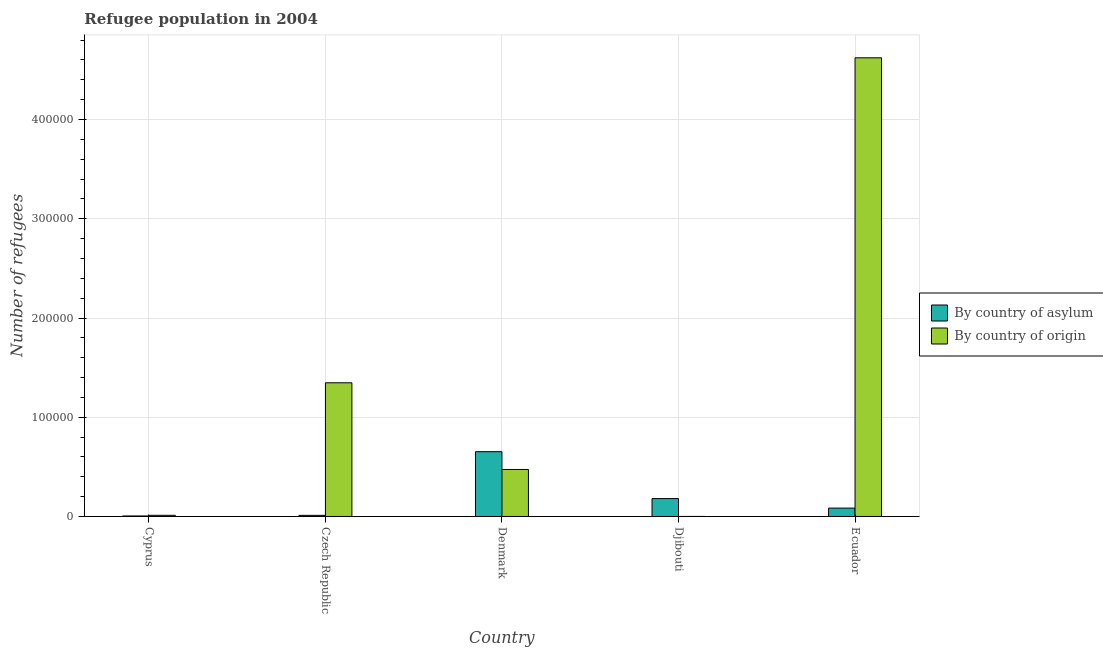Are the number of bars per tick equal to the number of legend labels?
Keep it short and to the point. Yes. How many bars are there on the 1st tick from the left?
Your answer should be compact. 2. What is the label of the 4th group of bars from the left?
Provide a succinct answer. Djibouti. In how many cases, is the number of bars for a given country not equal to the number of legend labels?
Your answer should be compact. 0. What is the number of refugees by country of origin in Czech Republic?
Your answer should be compact. 1.35e+05. Across all countries, what is the maximum number of refugees by country of asylum?
Your answer should be very brief. 6.53e+04. Across all countries, what is the minimum number of refugees by country of asylum?
Offer a terse response. 531. In which country was the number of refugees by country of origin minimum?
Ensure brevity in your answer.  Djibouti. What is the total number of refugees by country of origin in the graph?
Offer a very short reply. 6.46e+05. What is the difference between the number of refugees by country of asylum in Djibouti and that in Ecuador?
Provide a short and direct response. 9585. What is the difference between the number of refugees by country of asylum in Djibouti and the number of refugees by country of origin in Cyprus?
Provide a succinct answer. 1.68e+04. What is the average number of refugees by country of asylum per country?
Ensure brevity in your answer.  1.87e+04. What is the difference between the number of refugees by country of asylum and number of refugees by country of origin in Djibouti?
Provide a succinct answer. 1.80e+04. In how many countries, is the number of refugees by country of origin greater than 20000 ?
Give a very brief answer. 3. What is the ratio of the number of refugees by country of asylum in Cyprus to that in Czech Republic?
Your answer should be very brief. 0.46. Is the number of refugees by country of origin in Czech Republic less than that in Djibouti?
Provide a short and direct response. No. What is the difference between the highest and the second highest number of refugees by country of asylum?
Your answer should be very brief. 4.73e+04. What is the difference between the highest and the lowest number of refugees by country of asylum?
Provide a succinct answer. 6.48e+04. In how many countries, is the number of refugees by country of asylum greater than the average number of refugees by country of asylum taken over all countries?
Your answer should be very brief. 1. Is the sum of the number of refugees by country of asylum in Djibouti and Ecuador greater than the maximum number of refugees by country of origin across all countries?
Keep it short and to the point. No. What does the 2nd bar from the left in Ecuador represents?
Offer a very short reply. By country of origin. What does the 1st bar from the right in Djibouti represents?
Keep it short and to the point. By country of origin. How many bars are there?
Your response must be concise. 10. Are all the bars in the graph horizontal?
Offer a very short reply. No. What is the difference between two consecutive major ticks on the Y-axis?
Make the answer very short. 1.00e+05. How many legend labels are there?
Your answer should be very brief. 2. How are the legend labels stacked?
Make the answer very short. Vertical. What is the title of the graph?
Ensure brevity in your answer.  Refugee population in 2004. Does "Net National savings" appear as one of the legend labels in the graph?
Offer a very short reply. No. What is the label or title of the X-axis?
Give a very brief answer. Country. What is the label or title of the Y-axis?
Offer a very short reply. Number of refugees. What is the Number of refugees in By country of asylum in Cyprus?
Offer a terse response. 531. What is the Number of refugees of By country of origin in Cyprus?
Make the answer very short. 1194. What is the Number of refugees in By country of asylum in Czech Republic?
Your answer should be very brief. 1144. What is the Number of refugees of By country of origin in Czech Republic?
Provide a short and direct response. 1.35e+05. What is the Number of refugees of By country of asylum in Denmark?
Give a very brief answer. 6.53e+04. What is the Number of refugees in By country of origin in Denmark?
Your answer should be compact. 4.74e+04. What is the Number of refugees in By country of asylum in Djibouti?
Ensure brevity in your answer.  1.80e+04. What is the Number of refugees in By country of origin in Djibouti?
Your answer should be very brief. 50. What is the Number of refugees of By country of asylum in Ecuador?
Your response must be concise. 8450. What is the Number of refugees of By country of origin in Ecuador?
Ensure brevity in your answer.  4.62e+05. Across all countries, what is the maximum Number of refugees in By country of asylum?
Make the answer very short. 6.53e+04. Across all countries, what is the maximum Number of refugees in By country of origin?
Your answer should be very brief. 4.62e+05. Across all countries, what is the minimum Number of refugees of By country of asylum?
Give a very brief answer. 531. What is the total Number of refugees of By country of asylum in the graph?
Your answer should be compact. 9.35e+04. What is the total Number of refugees of By country of origin in the graph?
Keep it short and to the point. 6.46e+05. What is the difference between the Number of refugees of By country of asylum in Cyprus and that in Czech Republic?
Offer a very short reply. -613. What is the difference between the Number of refugees in By country of origin in Cyprus and that in Czech Republic?
Provide a succinct answer. -1.34e+05. What is the difference between the Number of refugees in By country of asylum in Cyprus and that in Denmark?
Your answer should be compact. -6.48e+04. What is the difference between the Number of refugees in By country of origin in Cyprus and that in Denmark?
Your answer should be very brief. -4.62e+04. What is the difference between the Number of refugees of By country of asylum in Cyprus and that in Djibouti?
Your response must be concise. -1.75e+04. What is the difference between the Number of refugees in By country of origin in Cyprus and that in Djibouti?
Keep it short and to the point. 1144. What is the difference between the Number of refugees in By country of asylum in Cyprus and that in Ecuador?
Make the answer very short. -7919. What is the difference between the Number of refugees in By country of origin in Cyprus and that in Ecuador?
Your answer should be compact. -4.61e+05. What is the difference between the Number of refugees of By country of asylum in Czech Republic and that in Denmark?
Your answer should be very brief. -6.42e+04. What is the difference between the Number of refugees of By country of origin in Czech Republic and that in Denmark?
Make the answer very short. 8.73e+04. What is the difference between the Number of refugees in By country of asylum in Czech Republic and that in Djibouti?
Keep it short and to the point. -1.69e+04. What is the difference between the Number of refugees in By country of origin in Czech Republic and that in Djibouti?
Keep it short and to the point. 1.35e+05. What is the difference between the Number of refugees in By country of asylum in Czech Republic and that in Ecuador?
Your answer should be very brief. -7306. What is the difference between the Number of refugees in By country of origin in Czech Republic and that in Ecuador?
Offer a very short reply. -3.27e+05. What is the difference between the Number of refugees of By country of asylum in Denmark and that in Djibouti?
Make the answer very short. 4.73e+04. What is the difference between the Number of refugees in By country of origin in Denmark and that in Djibouti?
Provide a short and direct response. 4.73e+04. What is the difference between the Number of refugees of By country of asylum in Denmark and that in Ecuador?
Your answer should be very brief. 5.69e+04. What is the difference between the Number of refugees in By country of origin in Denmark and that in Ecuador?
Give a very brief answer. -4.15e+05. What is the difference between the Number of refugees of By country of asylum in Djibouti and that in Ecuador?
Your response must be concise. 9585. What is the difference between the Number of refugees of By country of origin in Djibouti and that in Ecuador?
Your answer should be very brief. -4.62e+05. What is the difference between the Number of refugees in By country of asylum in Cyprus and the Number of refugees in By country of origin in Czech Republic?
Give a very brief answer. -1.34e+05. What is the difference between the Number of refugees in By country of asylum in Cyprus and the Number of refugees in By country of origin in Denmark?
Offer a very short reply. -4.68e+04. What is the difference between the Number of refugees in By country of asylum in Cyprus and the Number of refugees in By country of origin in Djibouti?
Provide a short and direct response. 481. What is the difference between the Number of refugees in By country of asylum in Cyprus and the Number of refugees in By country of origin in Ecuador?
Your answer should be very brief. -4.62e+05. What is the difference between the Number of refugees of By country of asylum in Czech Republic and the Number of refugees of By country of origin in Denmark?
Give a very brief answer. -4.62e+04. What is the difference between the Number of refugees of By country of asylum in Czech Republic and the Number of refugees of By country of origin in Djibouti?
Give a very brief answer. 1094. What is the difference between the Number of refugees of By country of asylum in Czech Republic and the Number of refugees of By country of origin in Ecuador?
Keep it short and to the point. -4.61e+05. What is the difference between the Number of refugees in By country of asylum in Denmark and the Number of refugees in By country of origin in Djibouti?
Provide a short and direct response. 6.53e+04. What is the difference between the Number of refugees of By country of asylum in Denmark and the Number of refugees of By country of origin in Ecuador?
Make the answer very short. -3.97e+05. What is the difference between the Number of refugees of By country of asylum in Djibouti and the Number of refugees of By country of origin in Ecuador?
Ensure brevity in your answer.  -4.44e+05. What is the average Number of refugees of By country of asylum per country?
Your answer should be compact. 1.87e+04. What is the average Number of refugees in By country of origin per country?
Your answer should be compact. 1.29e+05. What is the difference between the Number of refugees of By country of asylum and Number of refugees of By country of origin in Cyprus?
Make the answer very short. -663. What is the difference between the Number of refugees in By country of asylum and Number of refugees in By country of origin in Czech Republic?
Make the answer very short. -1.34e+05. What is the difference between the Number of refugees in By country of asylum and Number of refugees in By country of origin in Denmark?
Your answer should be very brief. 1.79e+04. What is the difference between the Number of refugees in By country of asylum and Number of refugees in By country of origin in Djibouti?
Ensure brevity in your answer.  1.80e+04. What is the difference between the Number of refugees in By country of asylum and Number of refugees in By country of origin in Ecuador?
Provide a short and direct response. -4.54e+05. What is the ratio of the Number of refugees in By country of asylum in Cyprus to that in Czech Republic?
Your answer should be very brief. 0.46. What is the ratio of the Number of refugees of By country of origin in Cyprus to that in Czech Republic?
Make the answer very short. 0.01. What is the ratio of the Number of refugees in By country of asylum in Cyprus to that in Denmark?
Give a very brief answer. 0.01. What is the ratio of the Number of refugees in By country of origin in Cyprus to that in Denmark?
Your answer should be very brief. 0.03. What is the ratio of the Number of refugees of By country of asylum in Cyprus to that in Djibouti?
Provide a short and direct response. 0.03. What is the ratio of the Number of refugees in By country of origin in Cyprus to that in Djibouti?
Ensure brevity in your answer.  23.88. What is the ratio of the Number of refugees of By country of asylum in Cyprus to that in Ecuador?
Your response must be concise. 0.06. What is the ratio of the Number of refugees of By country of origin in Cyprus to that in Ecuador?
Provide a short and direct response. 0. What is the ratio of the Number of refugees of By country of asylum in Czech Republic to that in Denmark?
Offer a terse response. 0.02. What is the ratio of the Number of refugees in By country of origin in Czech Republic to that in Denmark?
Provide a short and direct response. 2.84. What is the ratio of the Number of refugees in By country of asylum in Czech Republic to that in Djibouti?
Give a very brief answer. 0.06. What is the ratio of the Number of refugees of By country of origin in Czech Republic to that in Djibouti?
Offer a very short reply. 2694.48. What is the ratio of the Number of refugees in By country of asylum in Czech Republic to that in Ecuador?
Your answer should be compact. 0.14. What is the ratio of the Number of refugees of By country of origin in Czech Republic to that in Ecuador?
Provide a succinct answer. 0.29. What is the ratio of the Number of refugees of By country of asylum in Denmark to that in Djibouti?
Offer a very short reply. 3.62. What is the ratio of the Number of refugees of By country of origin in Denmark to that in Djibouti?
Make the answer very short. 947.62. What is the ratio of the Number of refugees of By country of asylum in Denmark to that in Ecuador?
Your answer should be compact. 7.73. What is the ratio of the Number of refugees of By country of origin in Denmark to that in Ecuador?
Keep it short and to the point. 0.1. What is the ratio of the Number of refugees of By country of asylum in Djibouti to that in Ecuador?
Offer a terse response. 2.13. What is the ratio of the Number of refugees in By country of origin in Djibouti to that in Ecuador?
Your answer should be compact. 0. What is the difference between the highest and the second highest Number of refugees in By country of asylum?
Your answer should be compact. 4.73e+04. What is the difference between the highest and the second highest Number of refugees of By country of origin?
Make the answer very short. 3.27e+05. What is the difference between the highest and the lowest Number of refugees in By country of asylum?
Your answer should be very brief. 6.48e+04. What is the difference between the highest and the lowest Number of refugees of By country of origin?
Give a very brief answer. 4.62e+05. 